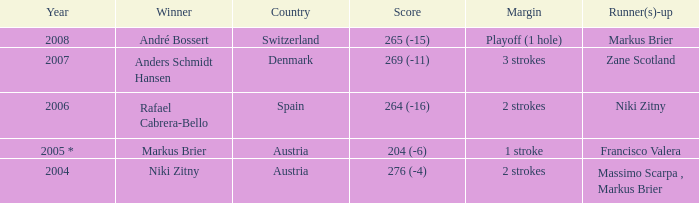When was the score recorded as 204 (-6)? 2005 *. 